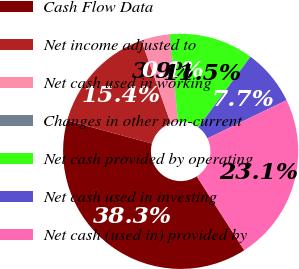Convert chart to OTSL. <chart><loc_0><loc_0><loc_500><loc_500><pie_chart><fcel>Cash Flow Data<fcel>Net income adjusted to<fcel>Net cash used in working<fcel>Changes in other non-current<fcel>Net cash provided by operating<fcel>Net cash used in investing<fcel>Net cash (used in) provided by<nl><fcel>38.31%<fcel>15.37%<fcel>3.9%<fcel>0.08%<fcel>11.55%<fcel>7.72%<fcel>23.07%<nl></chart> 